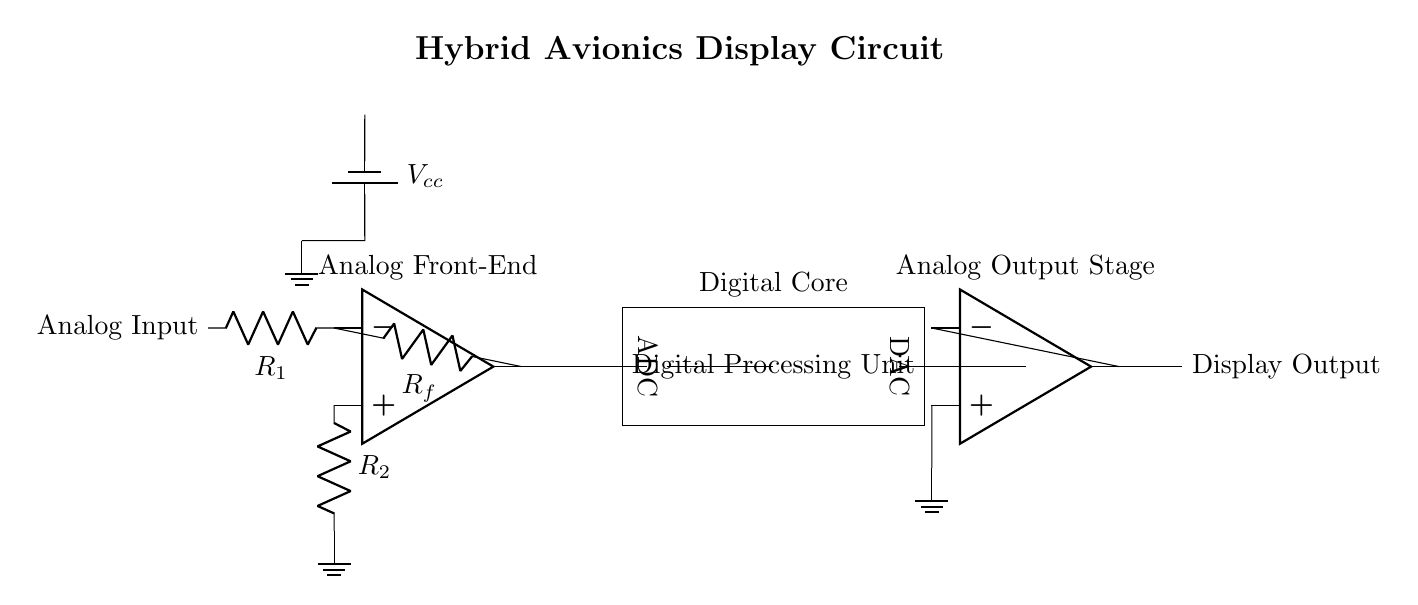What is the purpose of the op-amp in the circuit? The op-amp is used as an analog front-end to amplify the analog input signal before further processing.
Answer: Analog front-end What does the ADC do in this circuit? The ADC converts the amplified analog signal from the op-amp into a digital signal for processing by the digital unit.
Answer: Converts analog to digital What is the function of the Digital Processing Unit? The Digital Processing Unit processes the digital signal from the ADC and prepares it for conversion back to analog.
Answer: Signal processing What is the role of the DAC in this circuit? The DAC converts the digital output from the Digital Processing Unit back into an analog signal for display.
Answer: Converts digital to analog Which component connects the analog front-end to the digital core? The component that connects these two sections is the ADC, which takes the analog output from the op-amp and turns it into a digital signal.
Answer: ADC How is the power supplied in this circuit? The power is supplied by a battery indicated in the diagram, providing the necessary voltage for operation.
Answer: Battery What are the two main types of components shown in this hybrid circuit? The two main types of components are analog components (like op-amps and resistors) and digital components (like ADC, DAC, and processing unit).
Answer: Analog and digital components 